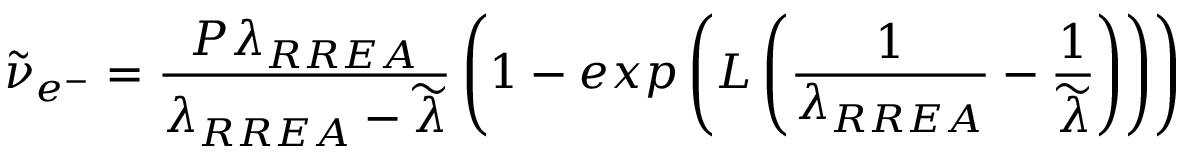<formula> <loc_0><loc_0><loc_500><loc_500>\widetilde { \nu } _ { e ^ { - } } = \frac { P \lambda _ { R R E A } } { \lambda _ { R R E A } - \widetilde { \lambda } } \left ( 1 - e x p \left ( L \left ( \frac { 1 } { \lambda _ { R R E A } } - \frac { 1 } { \widetilde { \lambda } } \right ) \right ) \right )</formula> 